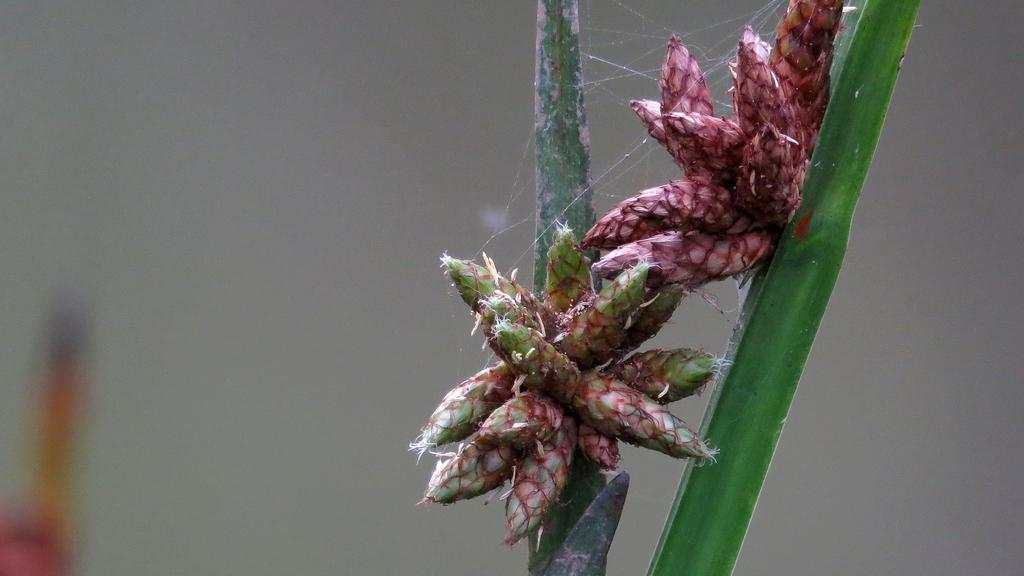How many flowers can be seen on the plant in the image? There are two flowers on a plant in the image. What can be observed about the background of the image? The background of the image is blurry. What date is marked on the calendar in the image? There is no calendar present in the image. How many nails are visible on the plant in the image? There are no nails present on the plant or in the image. 